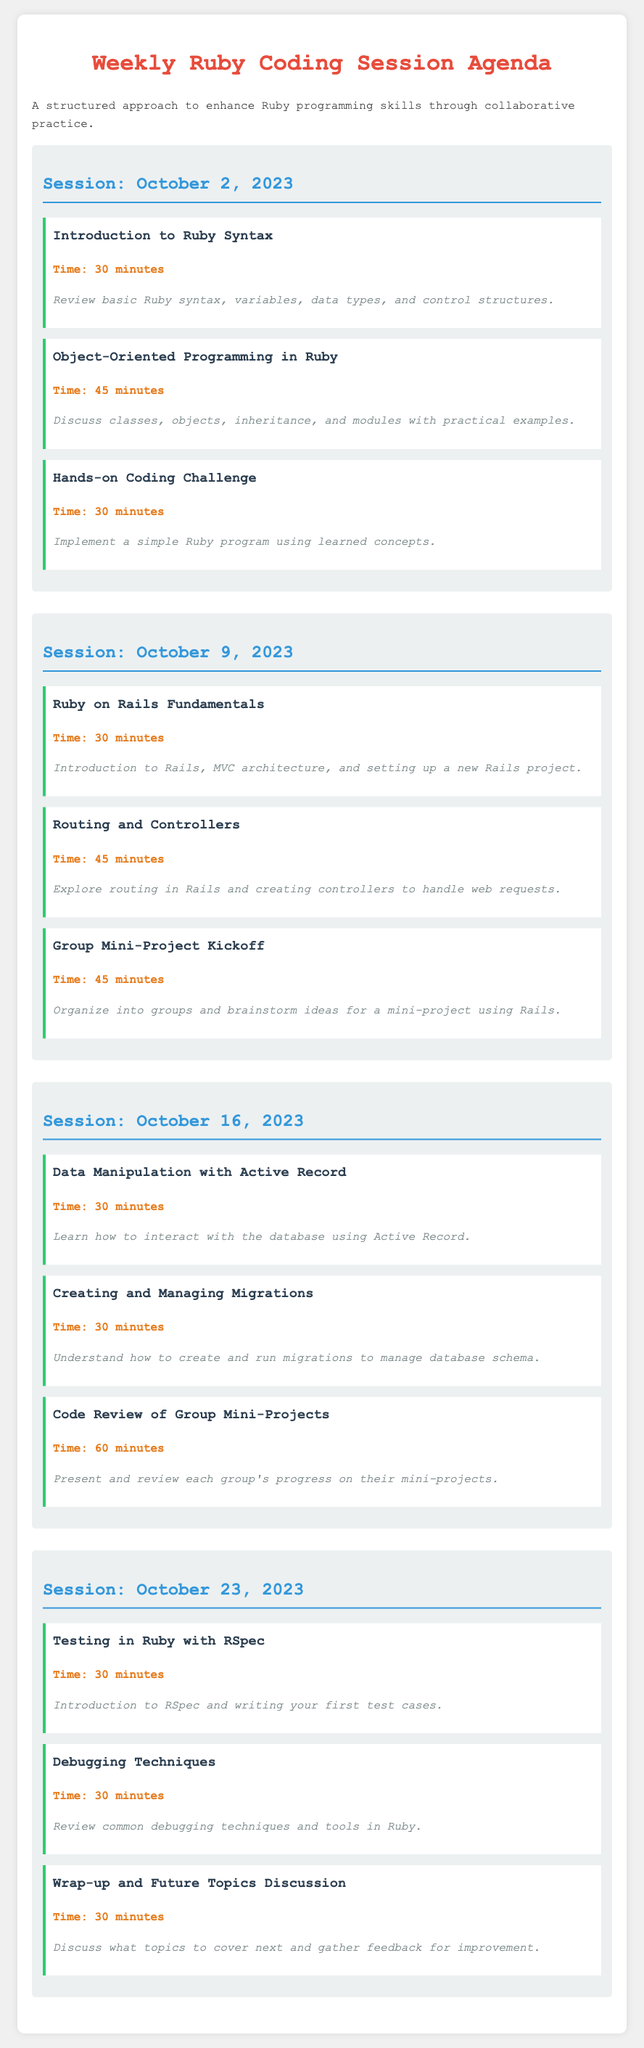What is the date of the first session? The date of the first session is indicated at the start of the first session section in the document.
Answer: October 2, 2023 How long is the "Object-Oriented Programming in Ruby" topic? The length of this topic is listed under its title in the agenda for that session.
Answer: 45 minutes What is the main focus of the session on October 9, 2023? The main focus is the first topic listed under the session date.
Answer: Ruby on Rails Fundamentals How much time is allocated for code review on October 16, 2023? The time allocation is provided next to the corresponding topic title in that session.
Answer: 60 minutes What is the last topic discussed in the session on October 23, 2023? The last topic can be identified by looking at the topics listed for that date in the document.
Answer: Wrap-up and Future Topics Discussion What type of programming does the agenda emphasize? The agenda repeatedly references specific programming topics throughout its sections.
Answer: Ruby Which session includes "Hands-on Coding Challenge"? The session can be found by checking the topics listed under each session date until the correct one is identified.
Answer: October 2, 2023 Which technique is covered for debugging in the session on October 23, 2023? The topic can be found under that specific session's topics in the document.
Answer: Debugging Techniques 